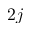<formula> <loc_0><loc_0><loc_500><loc_500>2 j</formula> 